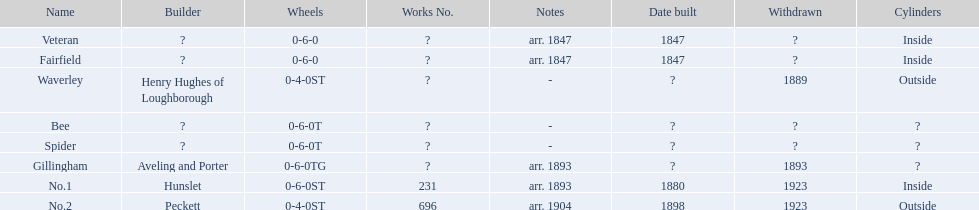Could you parse the entire table as a dict? {'header': ['Name', 'Builder', 'Wheels', 'Works No.', 'Notes', 'Date built', 'Withdrawn', 'Cylinders'], 'rows': [['Veteran', '?', '0-6-0', '?', 'arr. 1847', '1847', '?', 'Inside'], ['Fairfield', '?', '0-6-0', '?', 'arr. 1847', '1847', '?', 'Inside'], ['Waverley', 'Henry Hughes of Loughborough', '0-4-0ST', '?', '-', '?', '1889', 'Outside'], ['Bee', '?', '0-6-0T', '?', '-', '?', '?', '?'], ['Spider', '?', '0-6-0T', '?', '-', '?', '?', '?'], ['Gillingham', 'Aveling and Porter', '0-6-0TG', '?', 'arr. 1893', '?', '1893', '?'], ['No.1', 'Hunslet', '0-6-0ST', '231', 'arr. 1893', '1880', '1923', 'Inside'], ['No.2', 'Peckett', '0-4-0ST', '696', 'arr. 1904', '1898', '1923', 'Outside']]} Which have known built dates? Veteran, Fairfield, No.1, No.2. What other was built in 1847? Veteran. 